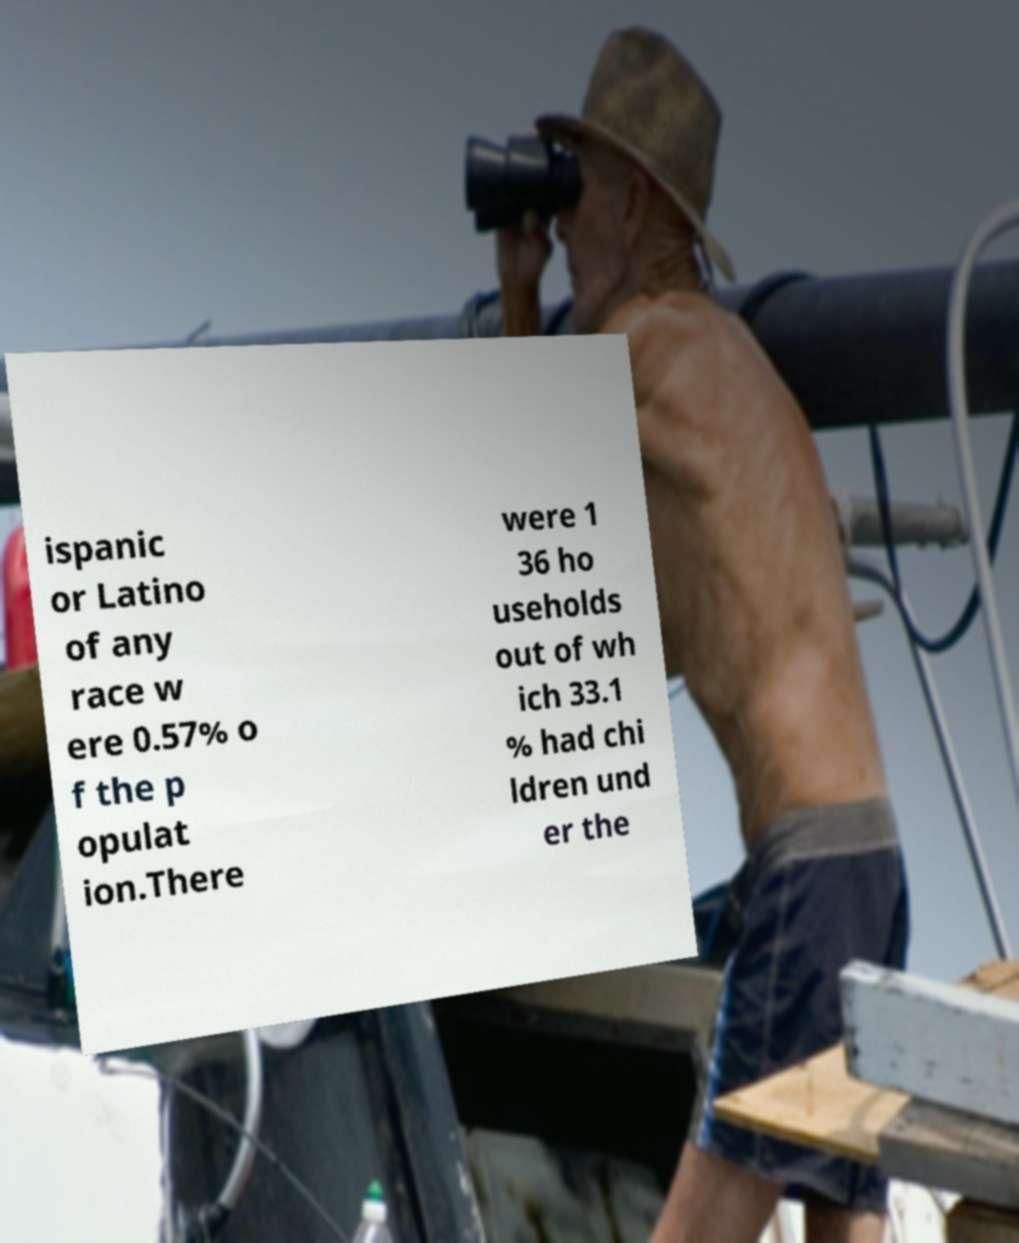I need the written content from this picture converted into text. Can you do that? ispanic or Latino of any race w ere 0.57% o f the p opulat ion.There were 1 36 ho useholds out of wh ich 33.1 % had chi ldren und er the 